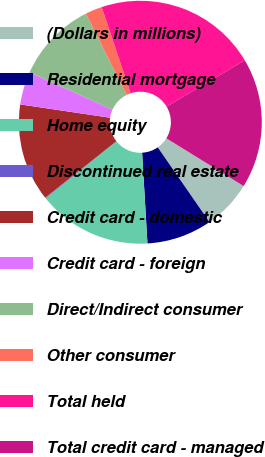Convert chart to OTSL. <chart><loc_0><loc_0><loc_500><loc_500><pie_chart><fcel>(Dollars in millions)<fcel>Residential mortgage<fcel>Home equity<fcel>Discontinued real estate<fcel>Credit card - domestic<fcel>Credit card - foreign<fcel>Direct/Indirect consumer<fcel>Other consumer<fcel>Total held<fcel>Total credit card - managed<nl><fcel>6.55%<fcel>8.71%<fcel>15.17%<fcel>0.09%<fcel>13.02%<fcel>4.4%<fcel>10.86%<fcel>2.24%<fcel>21.64%<fcel>17.33%<nl></chart> 